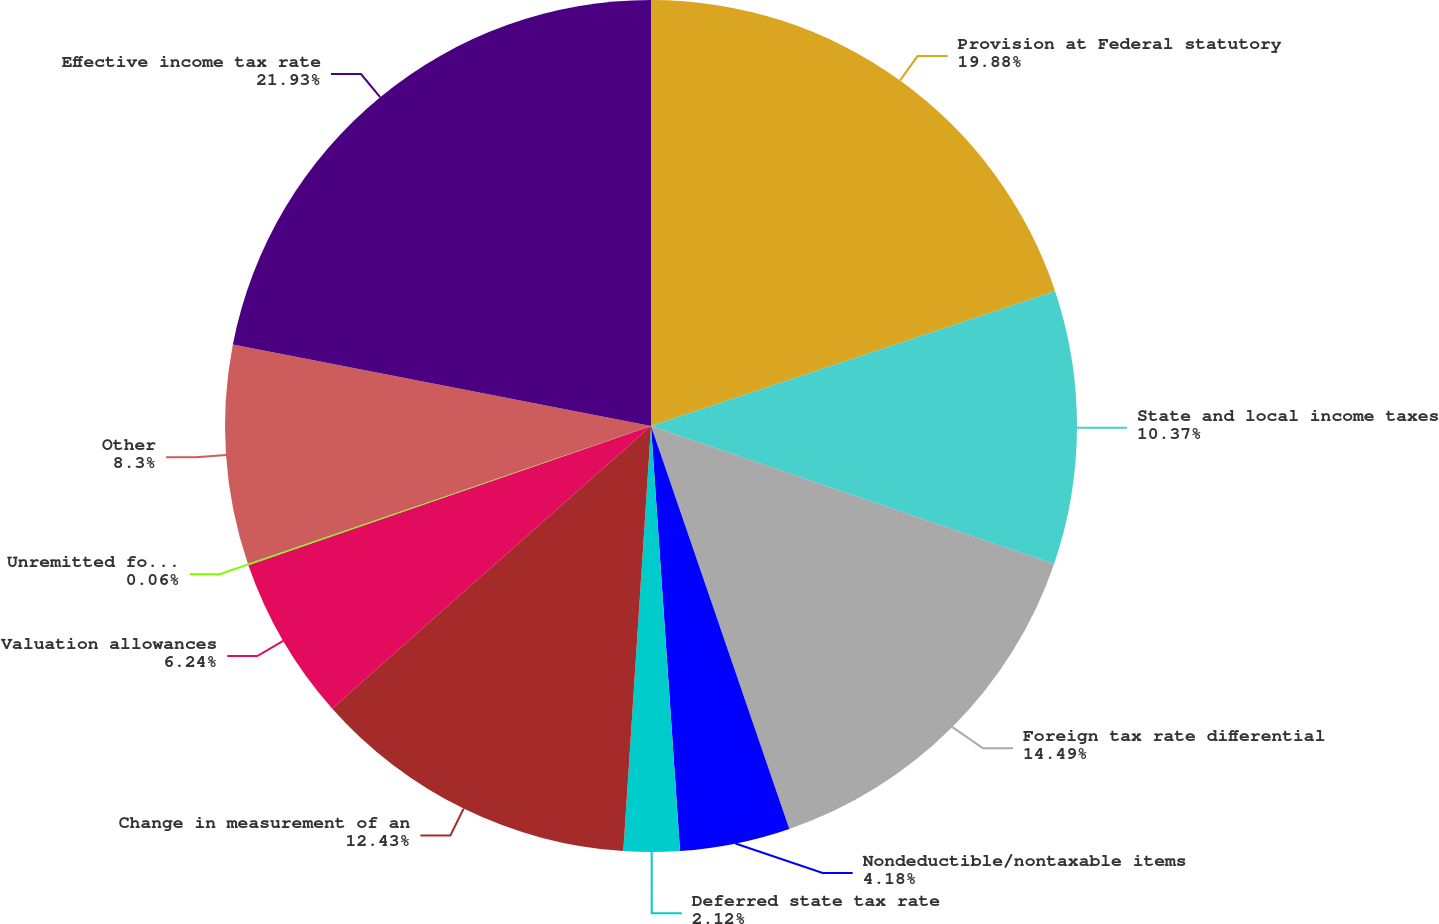Convert chart. <chart><loc_0><loc_0><loc_500><loc_500><pie_chart><fcel>Provision at Federal statutory<fcel>State and local income taxes<fcel>Foreign tax rate differential<fcel>Nondeductible/nontaxable items<fcel>Deferred state tax rate<fcel>Change in measurement of an<fcel>Valuation allowances<fcel>Unremitted foreign earnings<fcel>Other<fcel>Effective income tax rate<nl><fcel>19.88%<fcel>10.37%<fcel>14.49%<fcel>4.18%<fcel>2.12%<fcel>12.43%<fcel>6.24%<fcel>0.06%<fcel>8.3%<fcel>21.94%<nl></chart> 